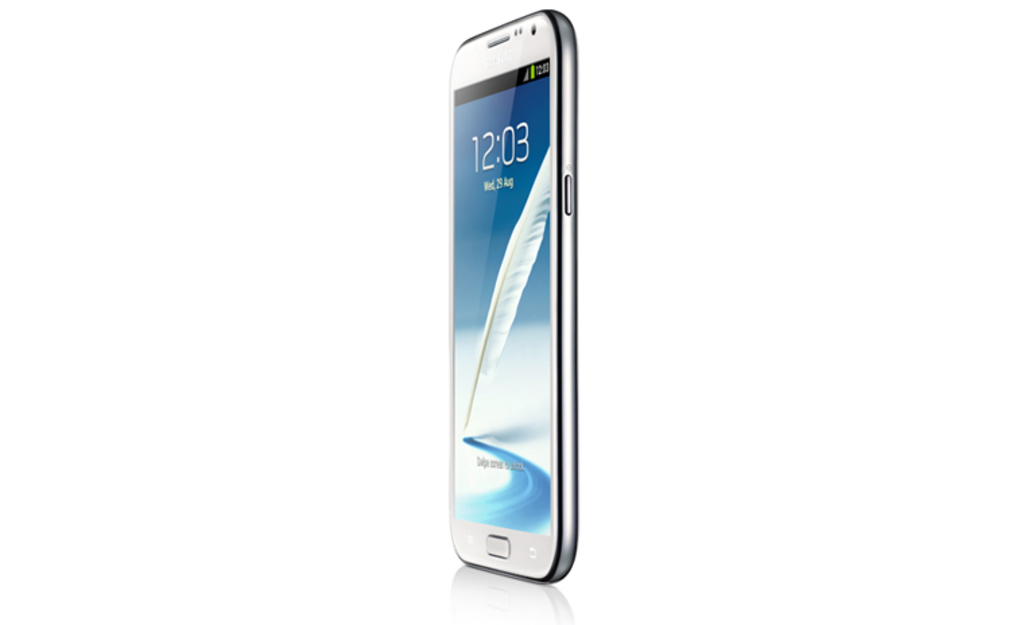Provide a one-sentence caption for the provided image. The image shows a modern smartphone displaying the time '12:03' and the date 'Wed, August 9' on its lock screen, with a visually appealing curved edge and pristine white background. 